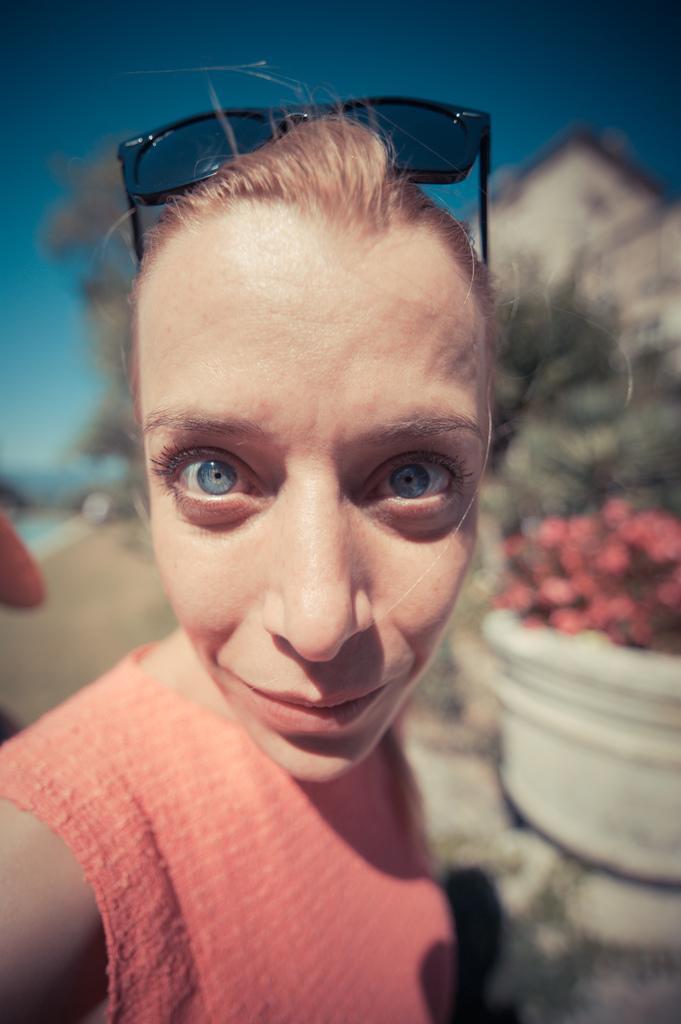Can you describe this image briefly? In this image we can see a woman. On the backside we can see some plants with flowers in a pot, a tree, a house, the hand of a person and the sky which looks cloudy. 